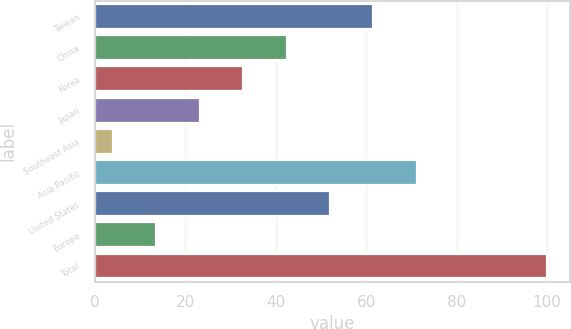Convert chart to OTSL. <chart><loc_0><loc_0><loc_500><loc_500><bar_chart><fcel>Taiwan<fcel>China<fcel>Korea<fcel>Japan<fcel>Southeast Asia<fcel>Asia Pacific<fcel>United States<fcel>Europe<fcel>Total<nl><fcel>61.6<fcel>42.4<fcel>32.8<fcel>23.2<fcel>4<fcel>71.2<fcel>52<fcel>13.6<fcel>100<nl></chart> 